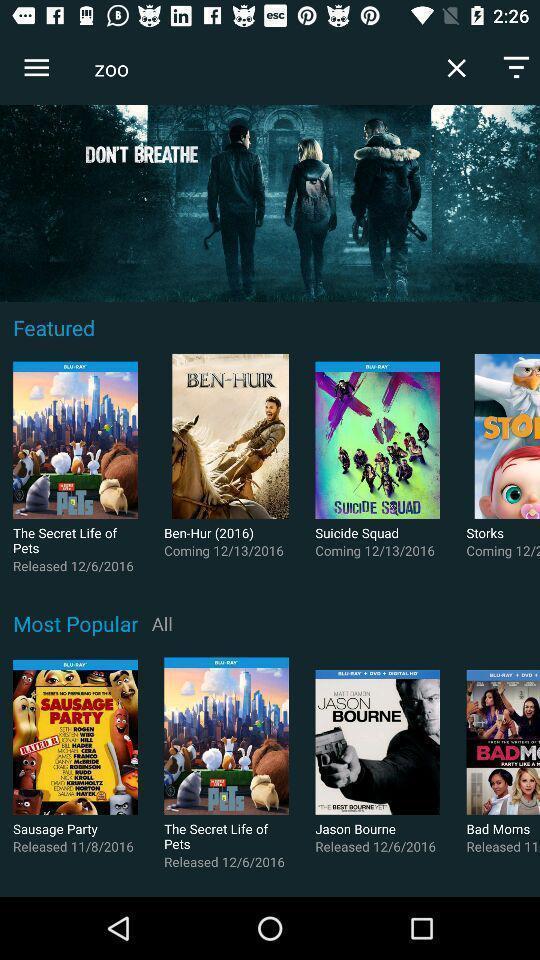What details can you identify in this image? Page displaying with list of various movies in application. 